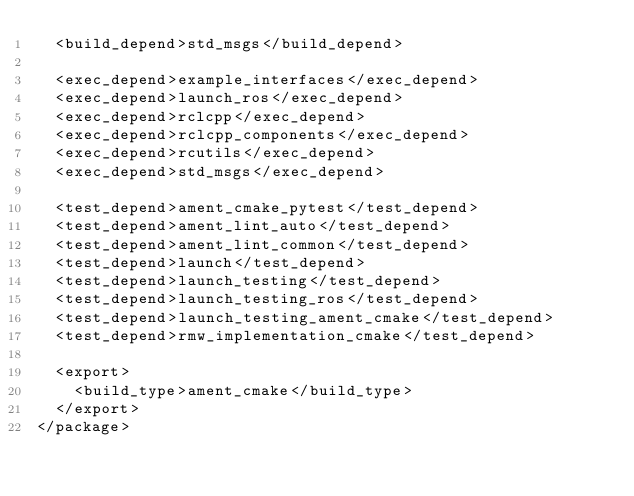<code> <loc_0><loc_0><loc_500><loc_500><_XML_>  <build_depend>std_msgs</build_depend>

  <exec_depend>example_interfaces</exec_depend>
  <exec_depend>launch_ros</exec_depend>
  <exec_depend>rclcpp</exec_depend>
  <exec_depend>rclcpp_components</exec_depend>
  <exec_depend>rcutils</exec_depend>
  <exec_depend>std_msgs</exec_depend>

  <test_depend>ament_cmake_pytest</test_depend>
  <test_depend>ament_lint_auto</test_depend>
  <test_depend>ament_lint_common</test_depend>
  <test_depend>launch</test_depend>
  <test_depend>launch_testing</test_depend>
  <test_depend>launch_testing_ros</test_depend>
  <test_depend>launch_testing_ament_cmake</test_depend>
  <test_depend>rmw_implementation_cmake</test_depend>

  <export>
    <build_type>ament_cmake</build_type>
  </export>
</package>
</code> 